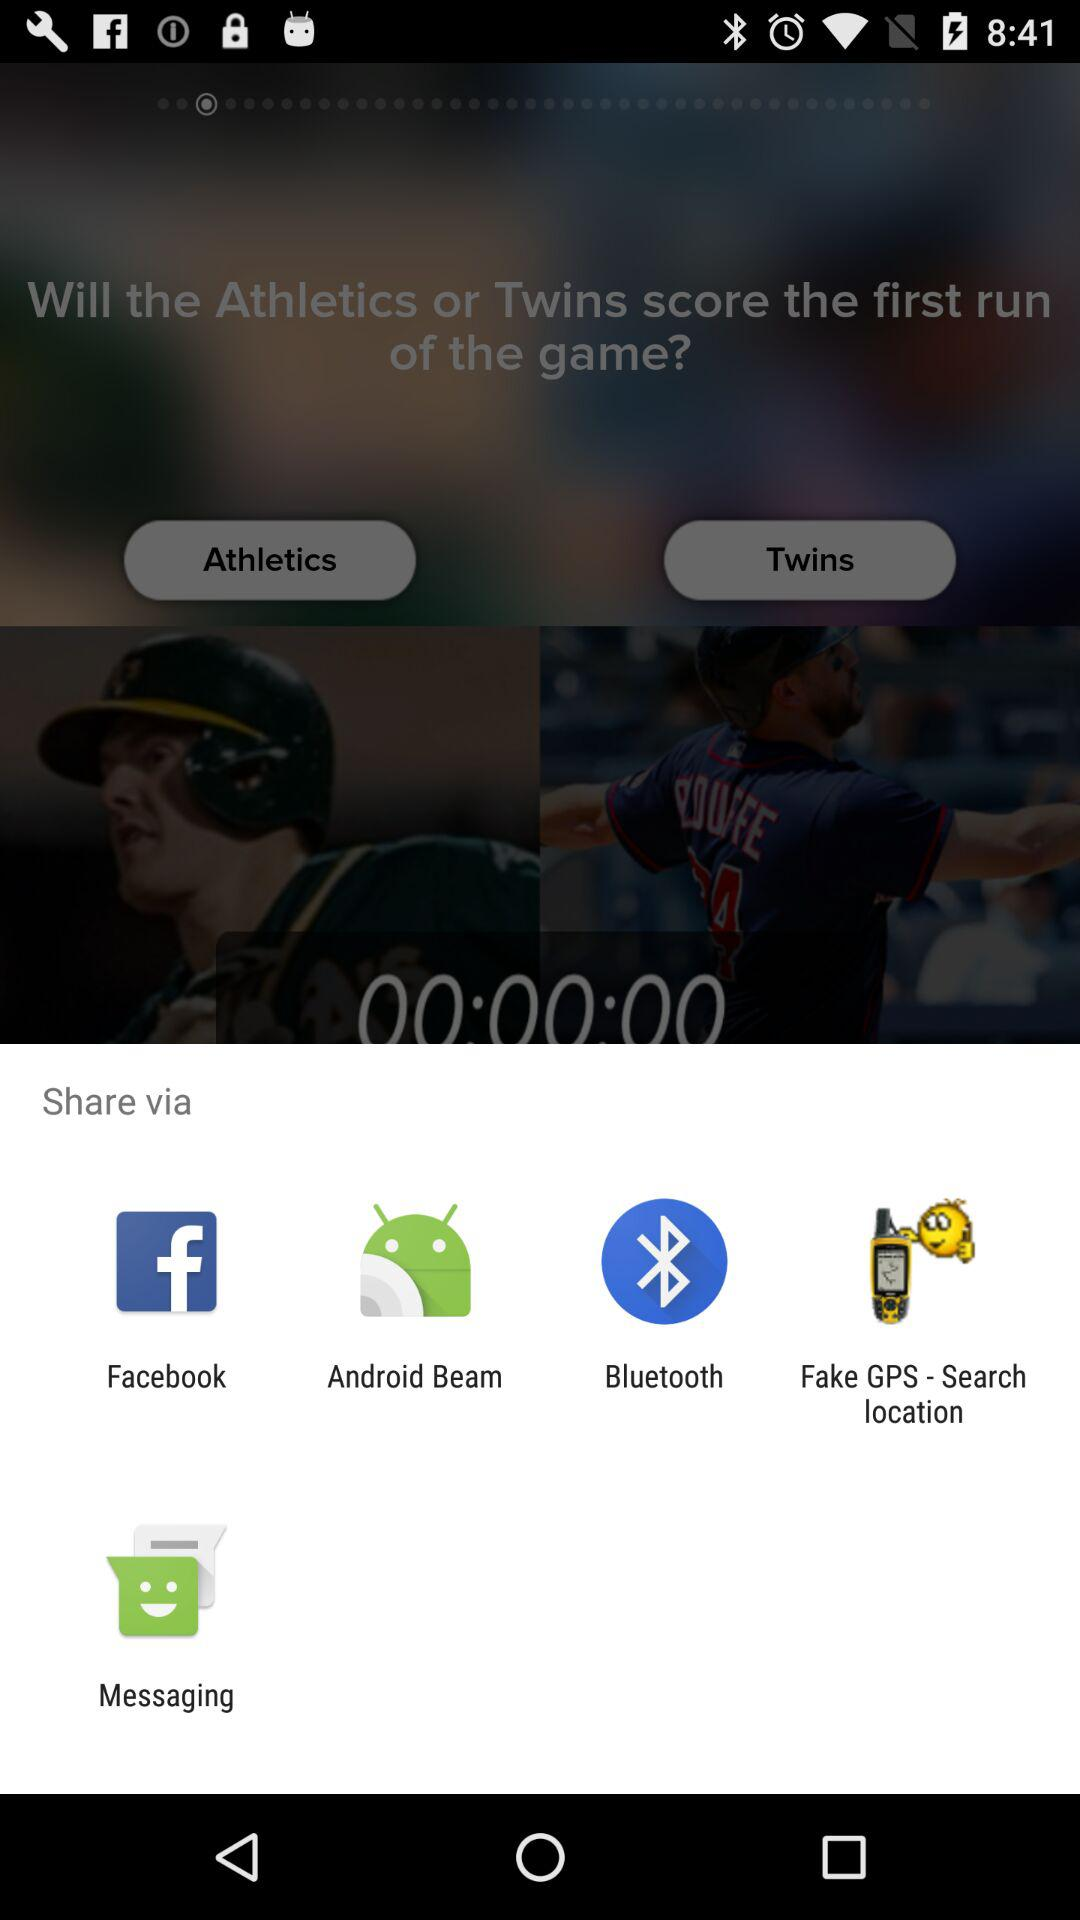Which application can I use for sharing the content? You can use "Facebook", "Android Beam", "Bluetooth", "Fake GPS - Search location" and "Messaging" for sharing the content. 